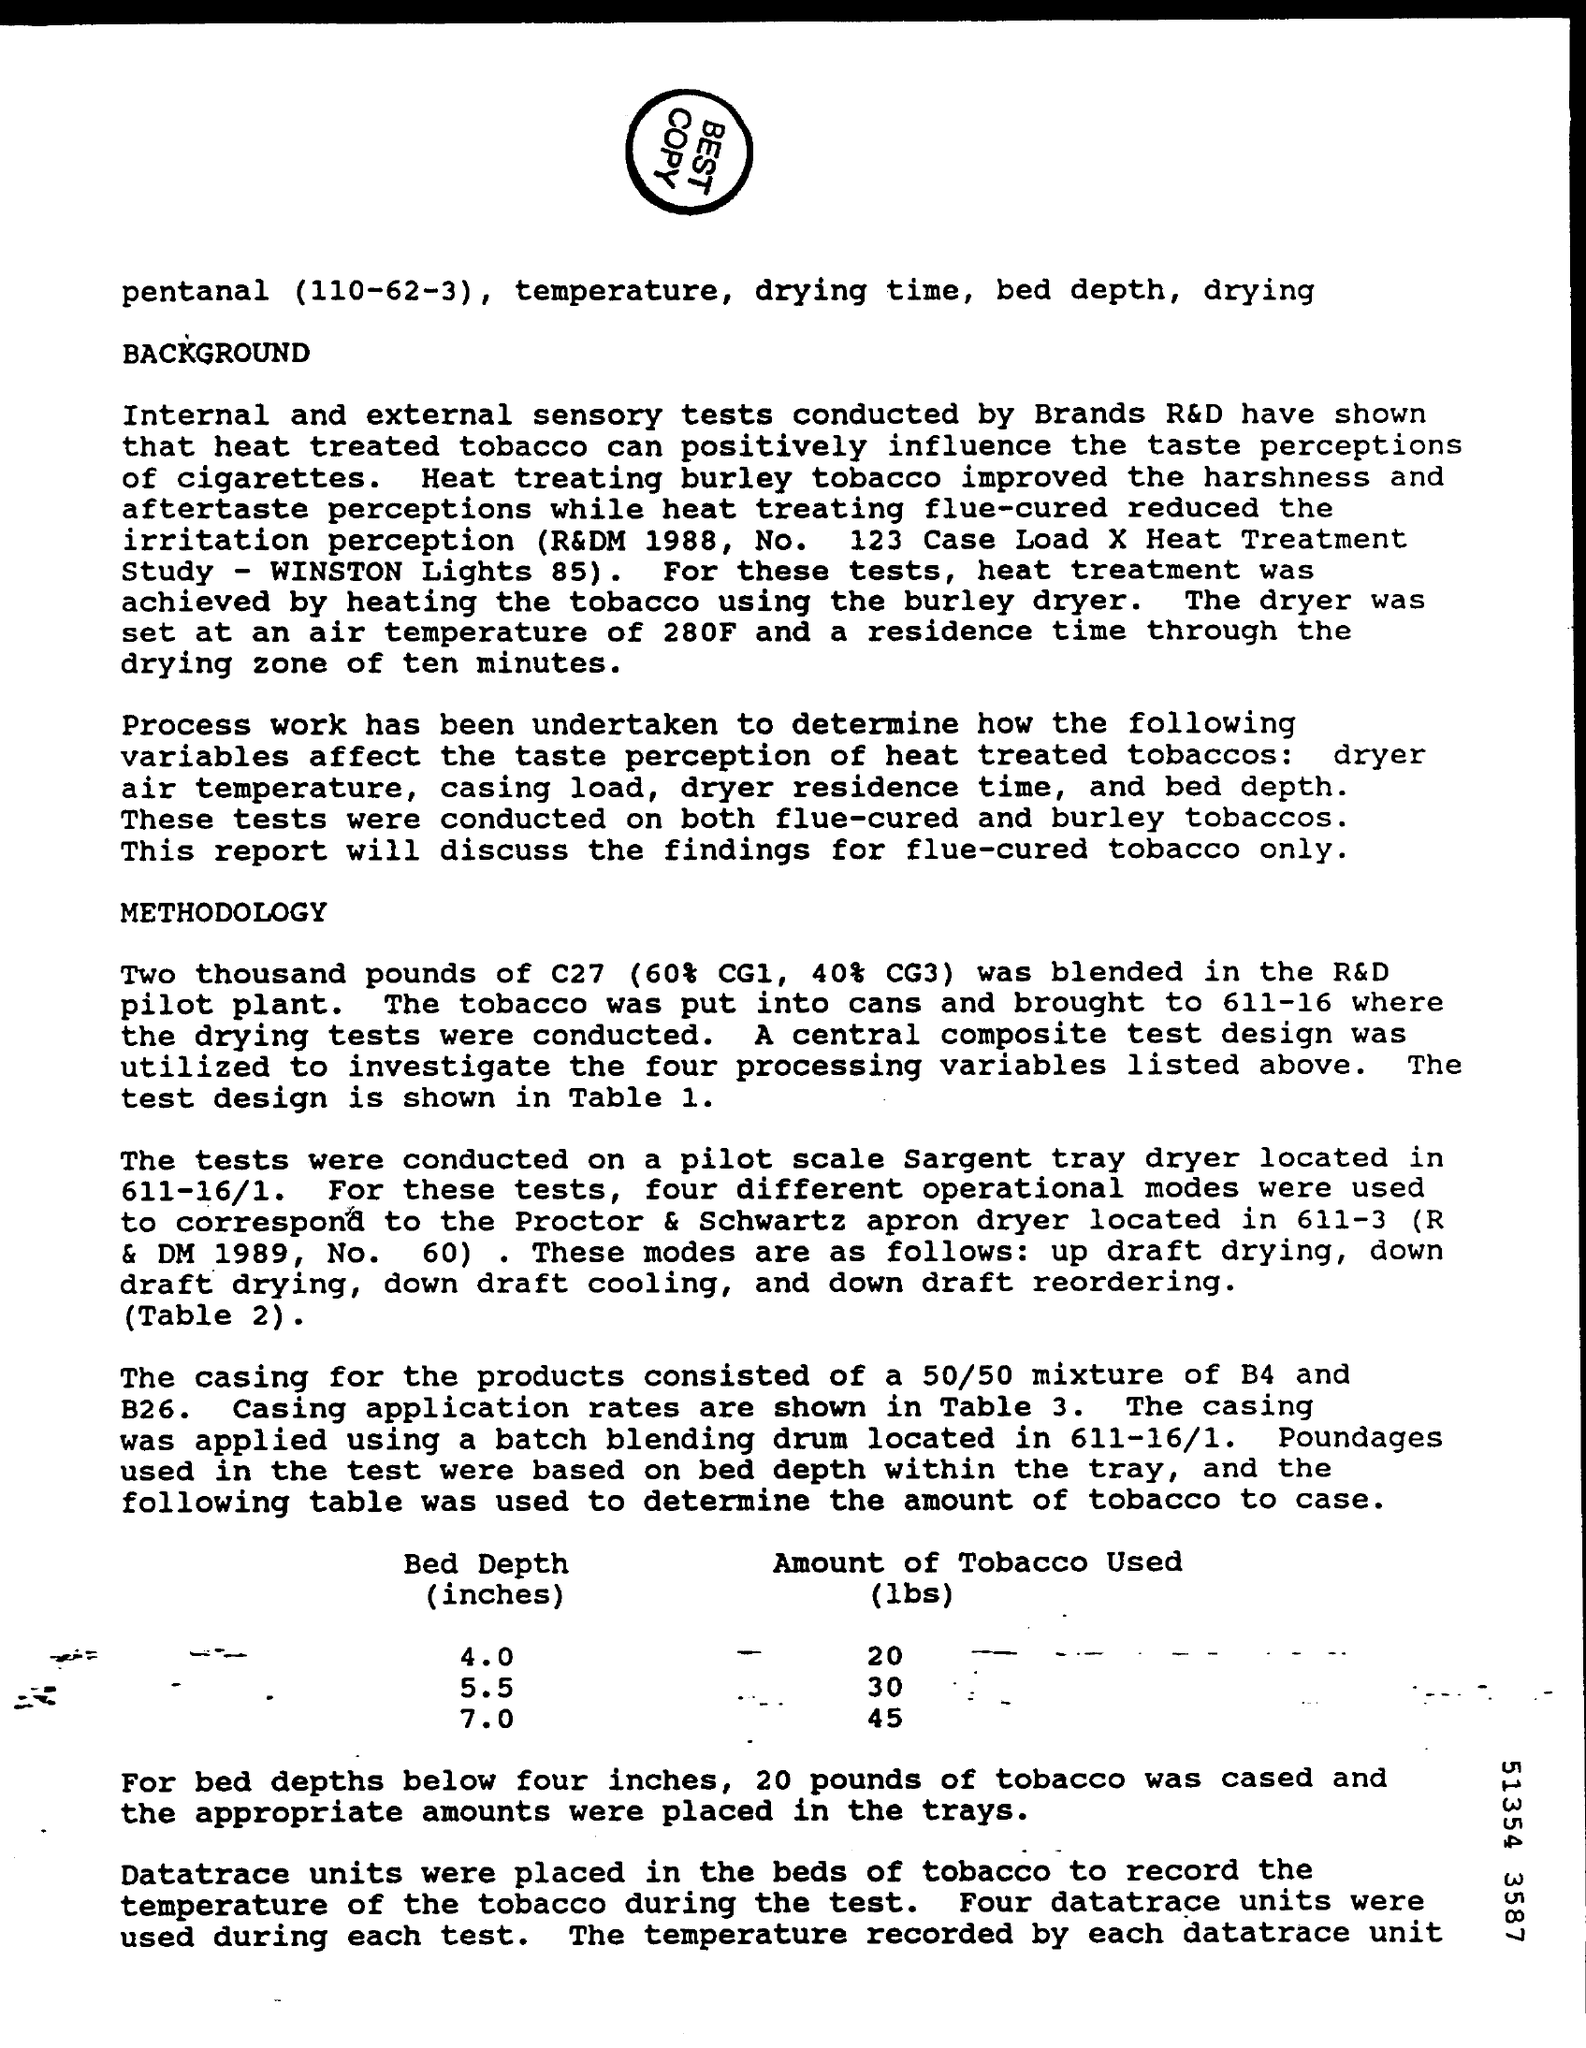What is the amount of tobacco use (lbs) for bed depth of 4.0 inches?
Your answer should be very brief. 20. What is the amount of tobacco use (lbs) for bed depth of 5.5 inches?
Ensure brevity in your answer.  30. What is the amount of tobacco use (lbs) for bed depth of 7.0 inches?
Keep it short and to the point. 45. 